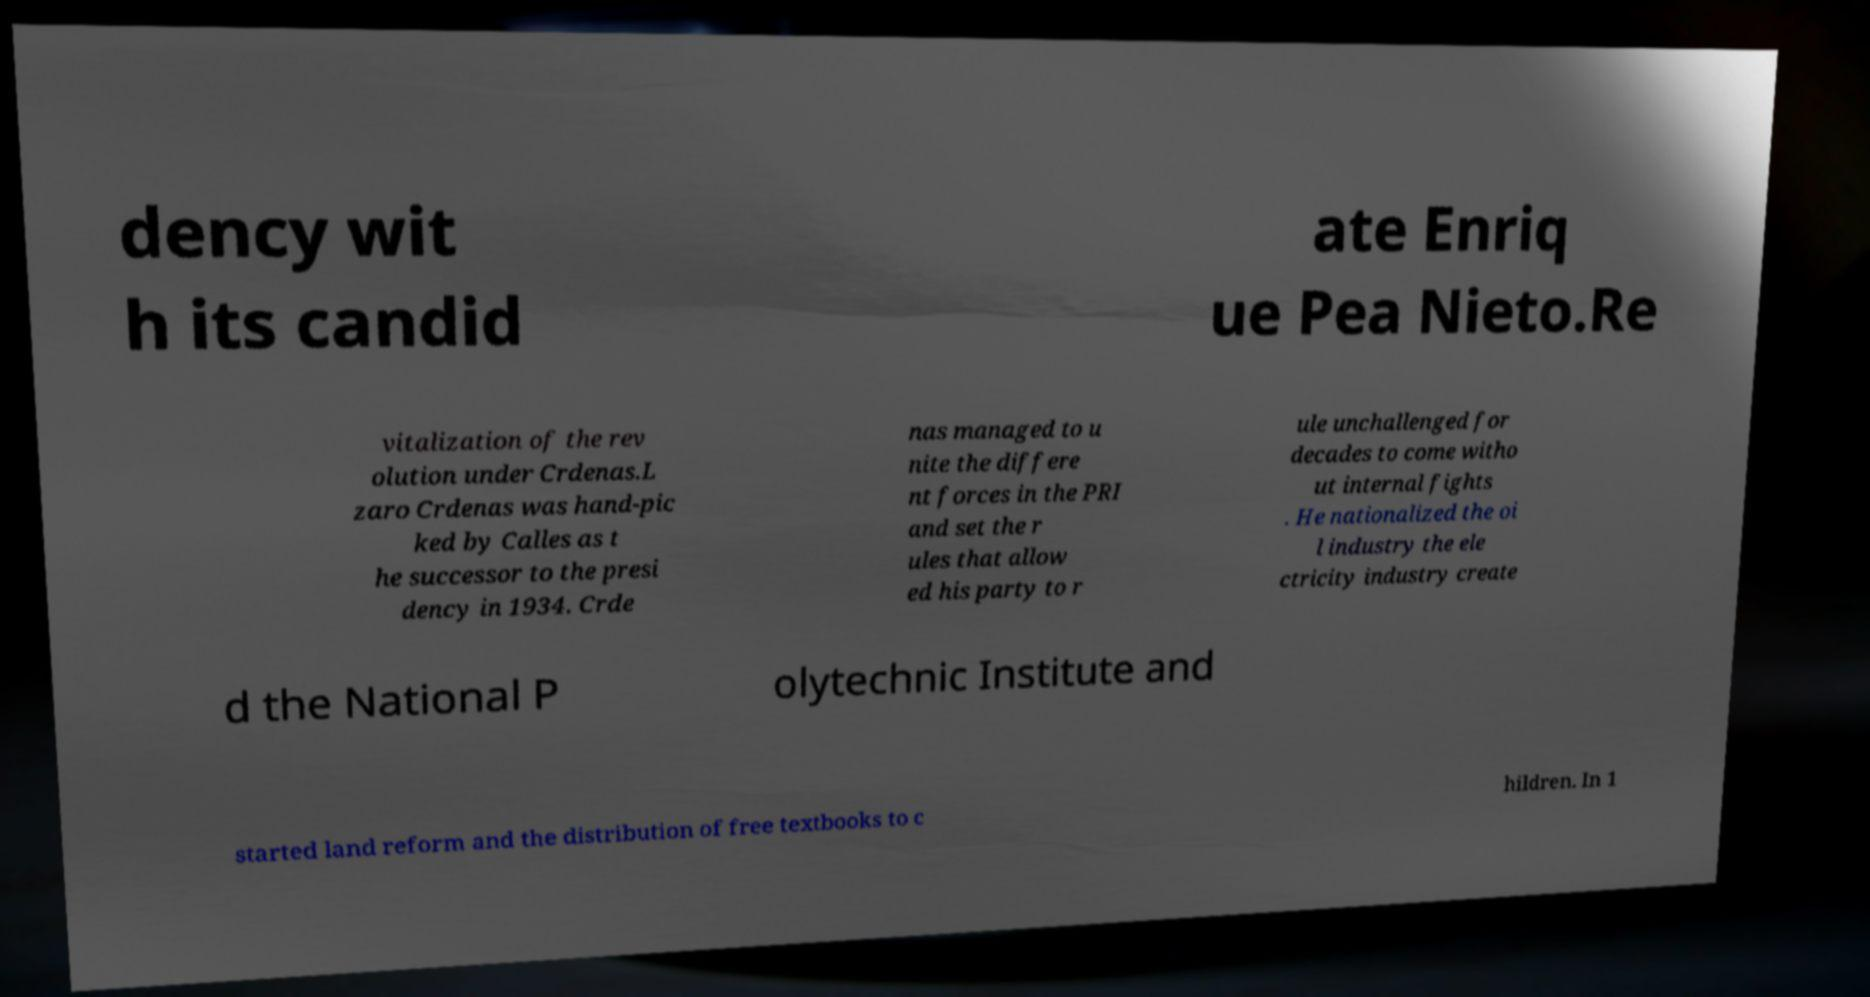Can you read and provide the text displayed in the image?This photo seems to have some interesting text. Can you extract and type it out for me? dency wit h its candid ate Enriq ue Pea Nieto.Re vitalization of the rev olution under Crdenas.L zaro Crdenas was hand-pic ked by Calles as t he successor to the presi dency in 1934. Crde nas managed to u nite the differe nt forces in the PRI and set the r ules that allow ed his party to r ule unchallenged for decades to come witho ut internal fights . He nationalized the oi l industry the ele ctricity industry create d the National P olytechnic Institute and started land reform and the distribution of free textbooks to c hildren. In 1 